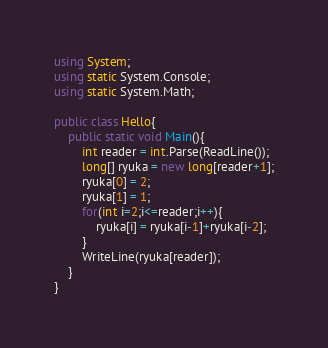Convert code to text. <code><loc_0><loc_0><loc_500><loc_500><_C#_>using System;
using static System.Console;
using static System.Math;

public class Hello{
    public static void Main(){
        int reader = int.Parse(ReadLine());
        long[] ryuka = new long[reader+1];
        ryuka[0] = 2;
        ryuka[1] = 1;
        for(int i=2;i<=reader;i++){
            ryuka[i] = ryuka[i-1]+ryuka[i-2];
        }
        WriteLine(ryuka[reader]);
    }
}</code> 